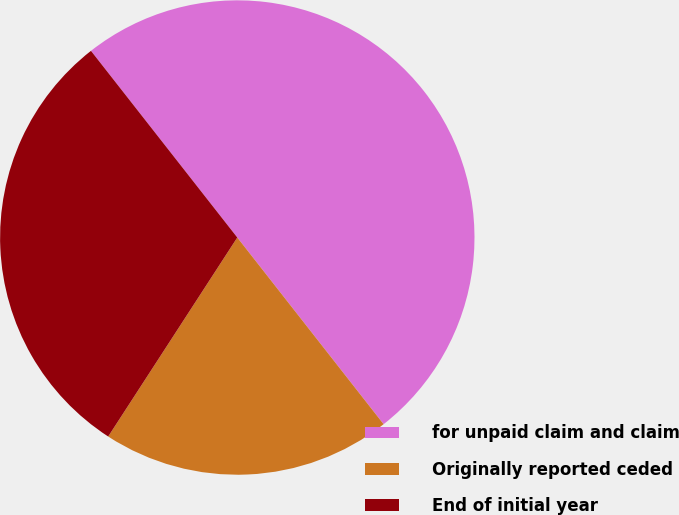<chart> <loc_0><loc_0><loc_500><loc_500><pie_chart><fcel>for unpaid claim and claim<fcel>Originally reported ceded<fcel>End of initial year<nl><fcel>50.0%<fcel>19.74%<fcel>30.26%<nl></chart> 